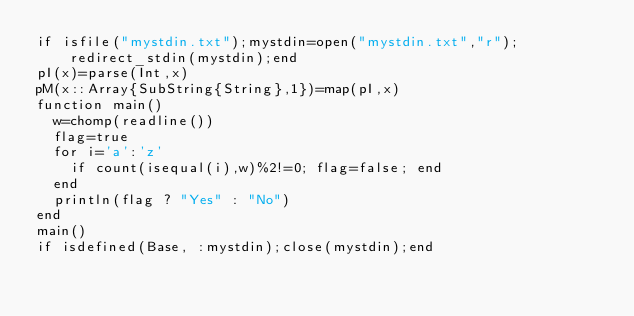<code> <loc_0><loc_0><loc_500><loc_500><_Julia_>if isfile("mystdin.txt");mystdin=open("mystdin.txt","r");redirect_stdin(mystdin);end
pI(x)=parse(Int,x)
pM(x::Array{SubString{String},1})=map(pI,x)
function main()
  w=chomp(readline())
  flag=true
  for i='a':'z'
    if count(isequal(i),w)%2!=0; flag=false; end
  end
  println(flag ? "Yes" : "No")
end
main()
if isdefined(Base, :mystdin);close(mystdin);end</code> 